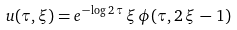Convert formula to latex. <formula><loc_0><loc_0><loc_500><loc_500>u ( \tau , \xi ) = e ^ { - \log 2 \, \tau } \, \xi \, \phi ( \tau , 2 \, \xi \, - \, 1 )</formula> 